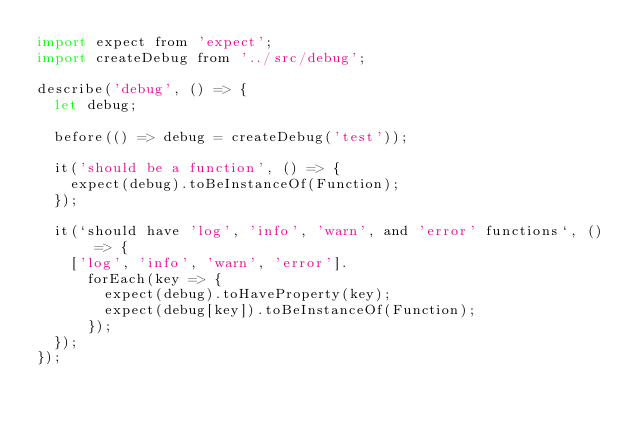Convert code to text. <code><loc_0><loc_0><loc_500><loc_500><_JavaScript_>import expect from 'expect';
import createDebug from '../src/debug';

describe('debug', () => {
  let debug;

  before(() => debug = createDebug('test'));

  it('should be a function', () => {
    expect(debug).toBeInstanceOf(Function);
  });

  it(`should have 'log', 'info', 'warn', and 'error' functions`, () => {
    ['log', 'info', 'warn', 'error'].
      forEach(key => {
        expect(debug).toHaveProperty(key);
        expect(debug[key]).toBeInstanceOf(Function);
      });
  });
});

</code> 